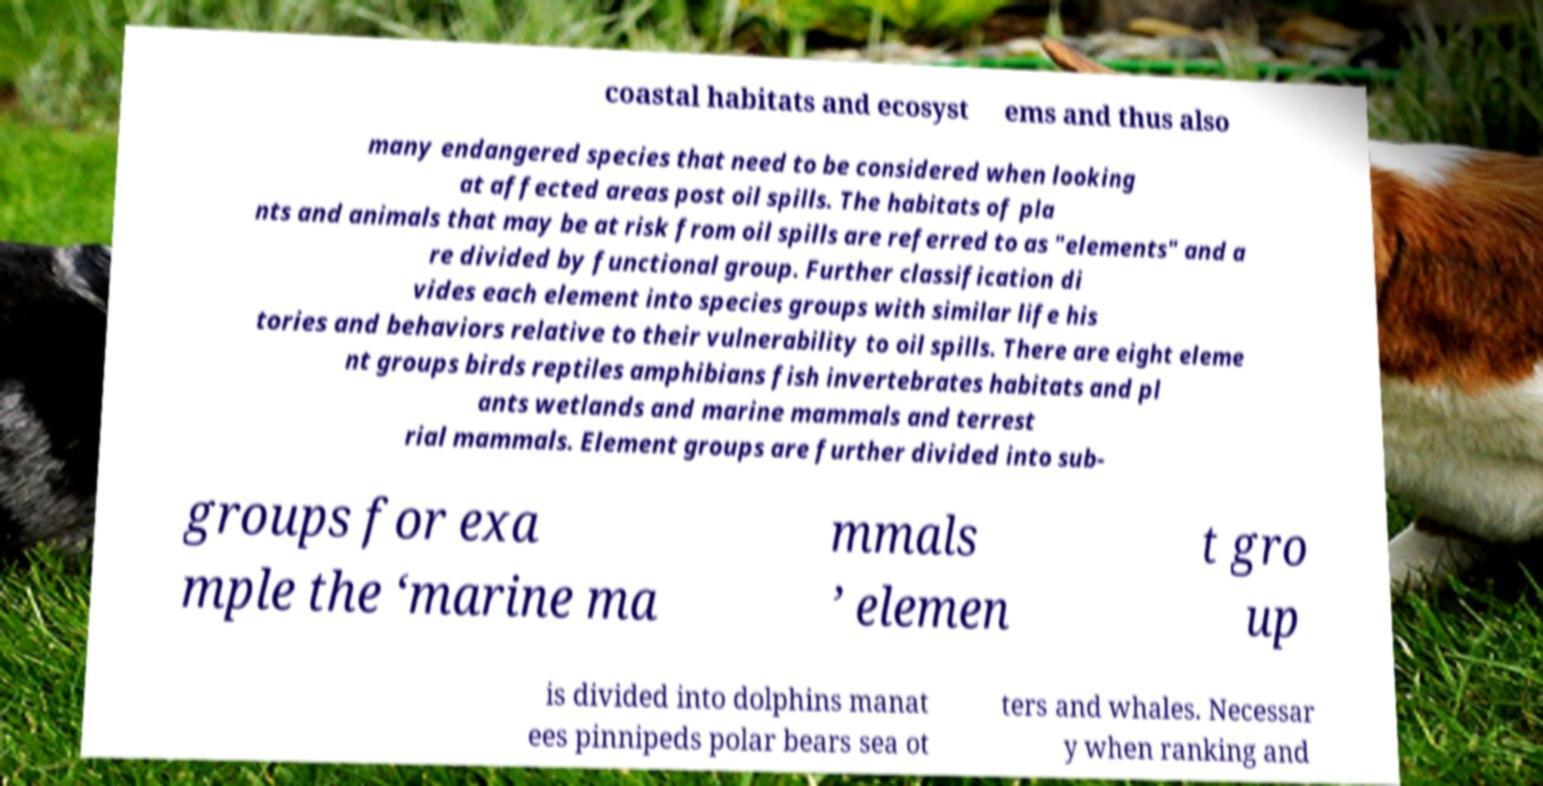Could you extract and type out the text from this image? coastal habitats and ecosyst ems and thus also many endangered species that need to be considered when looking at affected areas post oil spills. The habitats of pla nts and animals that may be at risk from oil spills are referred to as "elements" and a re divided by functional group. Further classification di vides each element into species groups with similar life his tories and behaviors relative to their vulnerability to oil spills. There are eight eleme nt groups birds reptiles amphibians fish invertebrates habitats and pl ants wetlands and marine mammals and terrest rial mammals. Element groups are further divided into sub- groups for exa mple the ‘marine ma mmals ’ elemen t gro up is divided into dolphins manat ees pinnipeds polar bears sea ot ters and whales. Necessar y when ranking and 